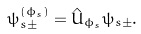<formula> <loc_0><loc_0><loc_500><loc_500>\psi _ { s \pm } ^ { ( \phi _ { s } ) } = \hat { U } _ { \phi _ { s } } \psi _ { s \pm } .</formula> 